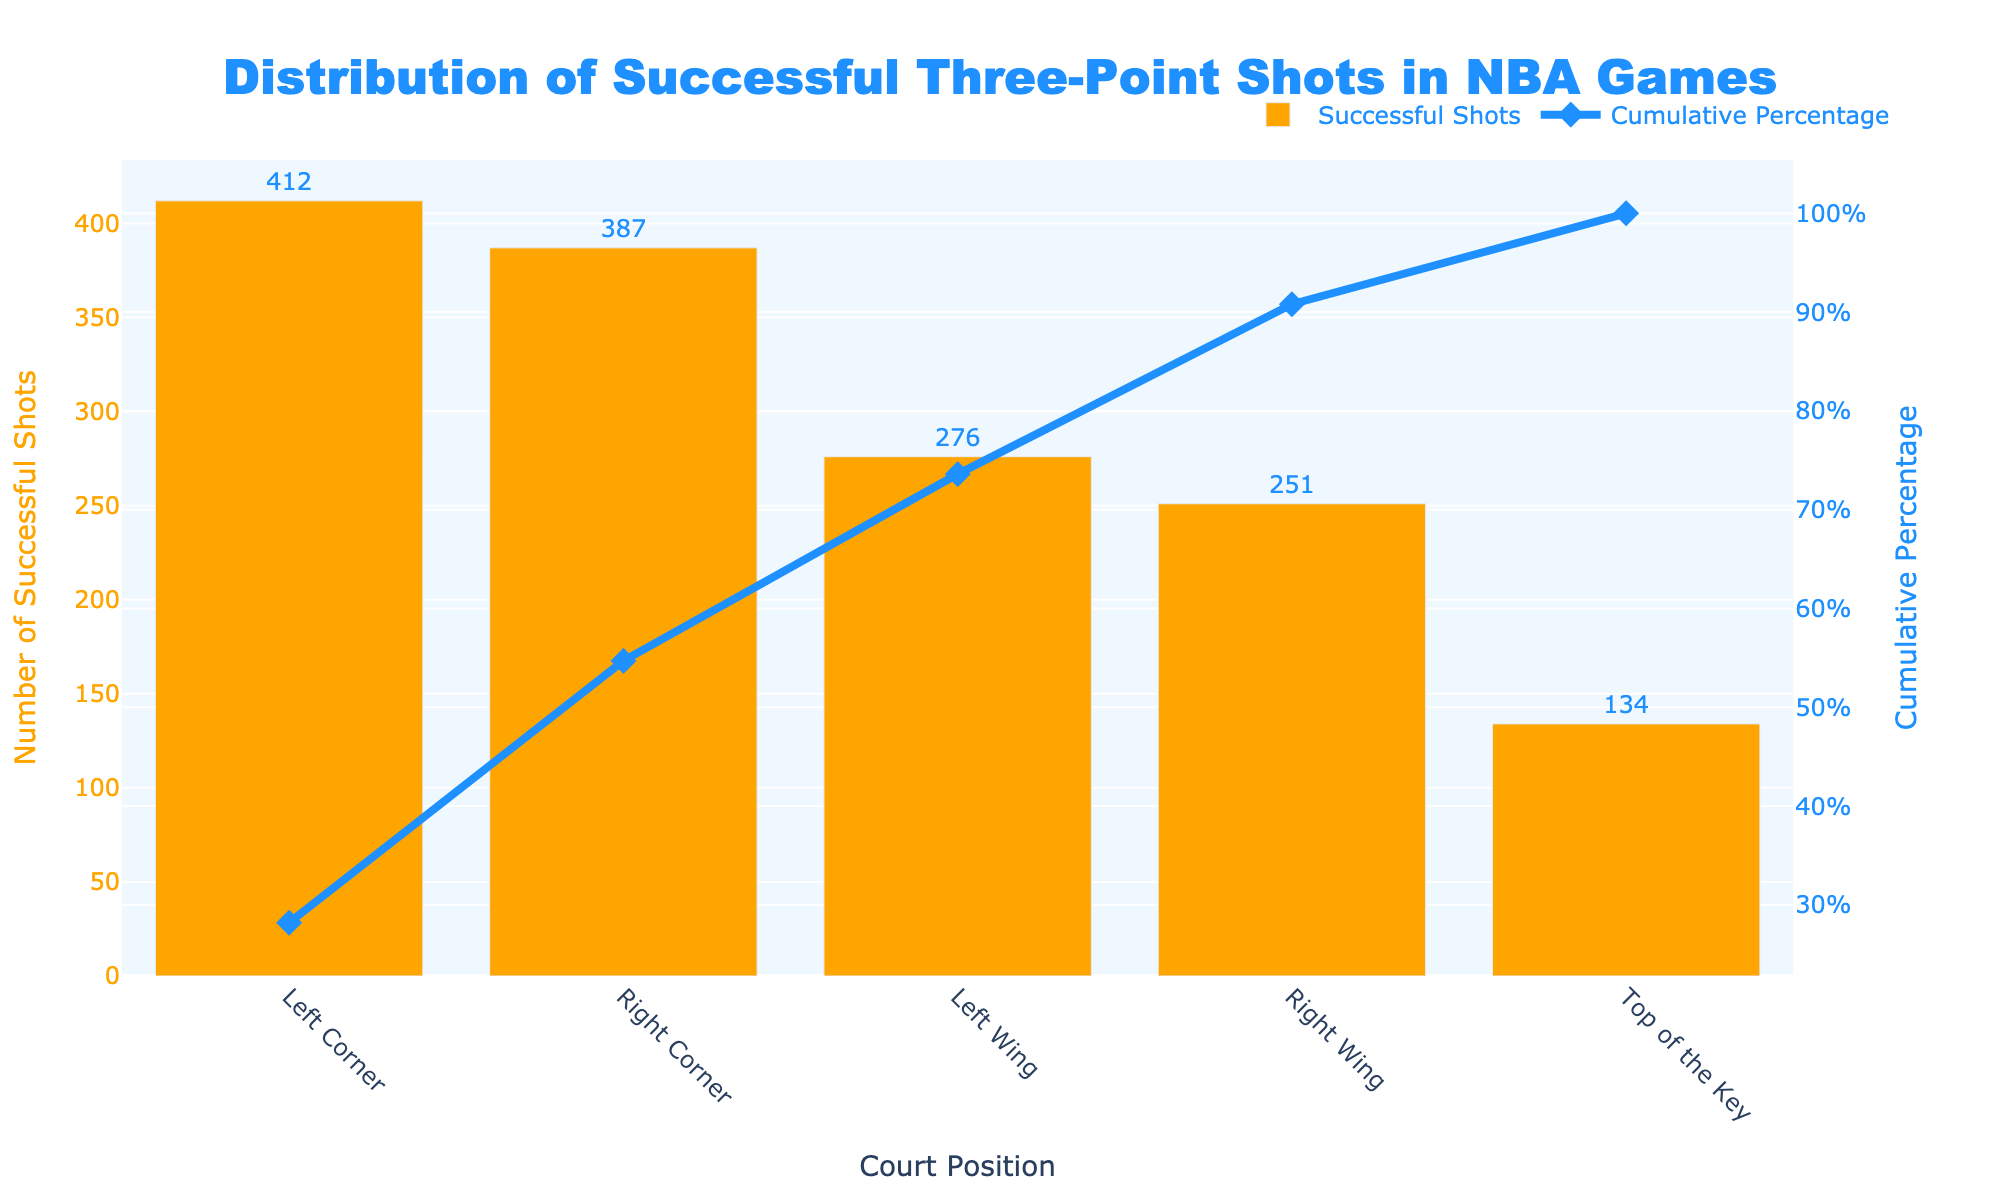Which court position has the highest number of successful three-point shots? The bar labeled "Left Corner" has the highest height, indicating that the Left Corner has the most successful three-point shots.
Answer: Left Corner What's the cumulative percentage of successful three-point shots by the time you reach the Right Wing? The point on the cumulative percentage line corresponding to "Right Wing" is at approximately 90.8%.
Answer: 90.8% How many more successful three-point shots are made from the Left Corner compared to the Top of the Key? The Left Corner has 412 successful shots, and the Top of the Key has 134 successful shots. The difference is 412 - 134 = 278.
Answer: 278 Which court positions together make up more than 50% of the cumulative successful three-point shots? The cumulative percentage passes 50% after adding the Right Corner, so positions Left Corner and Right Corner together make up more than 50%.
Answer: Left Corner, Right Corner What is the cumulative percentage after the Left Wing? Looking at the cumulative percentage line at the point labeled "Left Wing," the percentage is around 73.6%.
Answer: 73.6% Which has more successful three-point shots, the Right Corner or the Right Wing? The bar for the Right Corner is higher than the bar for the Right Wing, indicating more successful three-point shots.
Answer: Right Corner What positions account for the last 9.2% of cumulative successful three-point shots? The cumulative percentage at the Right Wing is 90.8%, so positions contributing after 90.8% are the Right Wing and the Top of the Key.
Answer: Right Wing, Top of the Key Which position has the closest number of successful three-point shots to 300? The closest value to 300 is the Left Wing with 276 successful shots.
Answer: Left Wing What is the total number of successful three-point shots for all the positions combined? Adding up the successful shots for all positions: 412 (Left Corner) + 387 (Right Corner) + 276 (Left Wing) + 251 (Right Wing) + 134 (Top of the Key) = 1460.
Answer: 1460 Which court position has the smallest number of successful three-point shots and what is its cumulative percentage? The bar for "Top of the Key" is the shortest, indicating the smallest number of shots at 134. The cumulative percentage for this position is 100.0%.
Answer: Top of the Key, 100.0% 